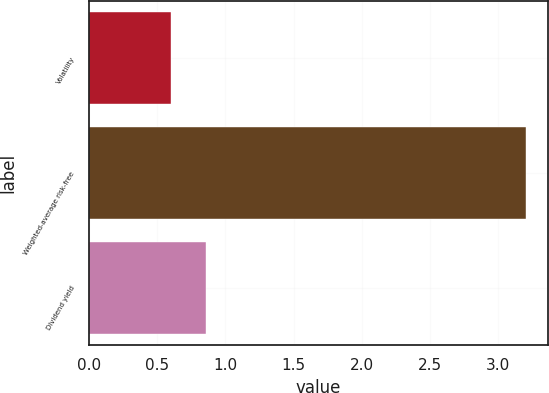<chart> <loc_0><loc_0><loc_500><loc_500><bar_chart><fcel>Volatility<fcel>Weighted-average risk-free<fcel>Dividend yield<nl><fcel>0.6<fcel>3.2<fcel>0.86<nl></chart> 